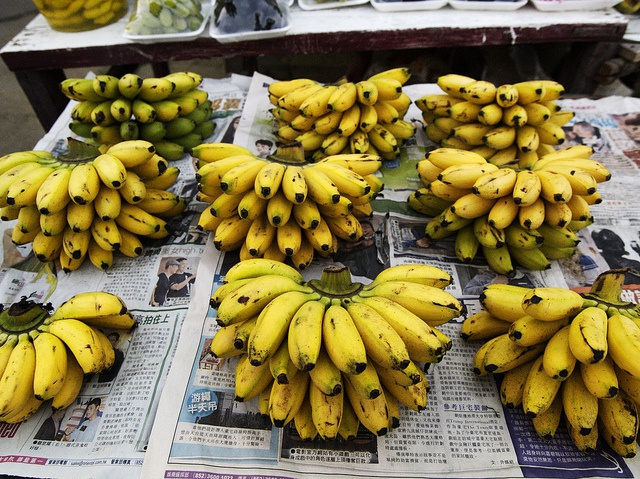Describe the objects in this image and their specific colors. I can see dining table in black, olive, darkgray, and lightgray tones, banana in black, gold, and olive tones, banana in black, olive, and khaki tones, dining table in black, lightgray, and darkgray tones, and banana in black and olive tones in this image. 